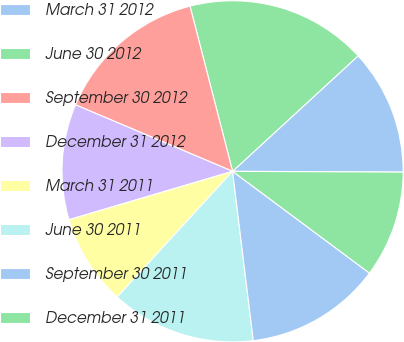Convert chart to OTSL. <chart><loc_0><loc_0><loc_500><loc_500><pie_chart><fcel>March 31 2012<fcel>June 30 2012<fcel>September 30 2012<fcel>December 31 2012<fcel>March 31 2011<fcel>June 30 2011<fcel>September 30 2011<fcel>December 31 2011<nl><fcel>11.91%<fcel>17.18%<fcel>14.61%<fcel>10.95%<fcel>8.61%<fcel>13.75%<fcel>12.89%<fcel>10.1%<nl></chart> 